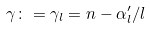Convert formula to latex. <formula><loc_0><loc_0><loc_500><loc_500>\gamma \colon = \gamma _ { l } = n - \alpha ^ { \prime } _ { l } / l</formula> 